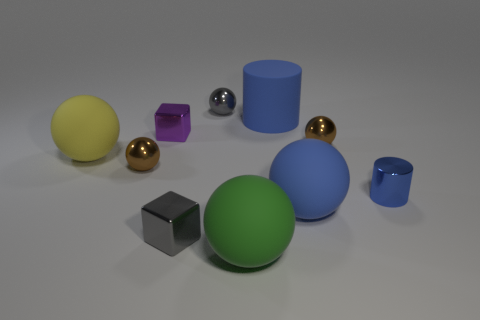Subtract all brown balls. How many balls are left? 4 Subtract all brown balls. How many balls are left? 4 Subtract all brown balls. Subtract all red cylinders. How many balls are left? 4 Subtract all balls. How many objects are left? 4 Subtract 0 red cylinders. How many objects are left? 10 Subtract all tiny yellow metal cubes. Subtract all small cylinders. How many objects are left? 9 Add 4 blue metal cylinders. How many blue metal cylinders are left? 5 Add 2 brown objects. How many brown objects exist? 4 